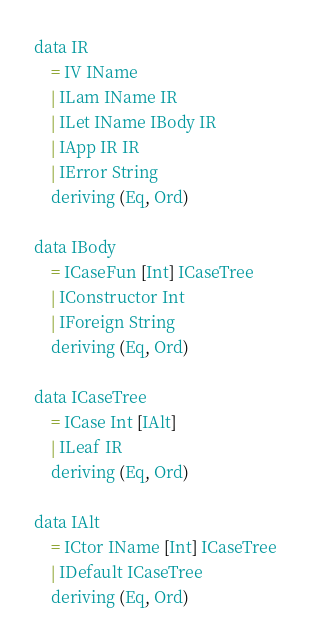<code> <loc_0><loc_0><loc_500><loc_500><_Haskell_>
data IR
    = IV IName
    | ILam IName IR
    | ILet IName IBody IR
    | IApp IR IR
    | IError String
    deriving (Eq, Ord)

data IBody
    = ICaseFun [Int] ICaseTree
    | IConstructor Int
    | IForeign String
    deriving (Eq, Ord)

data ICaseTree
    = ICase Int [IAlt]
    | ILeaf IR
    deriving (Eq, Ord)

data IAlt
    = ICtor IName [Int] ICaseTree
    | IDefault ICaseTree
    deriving (Eq, Ord)
</code> 